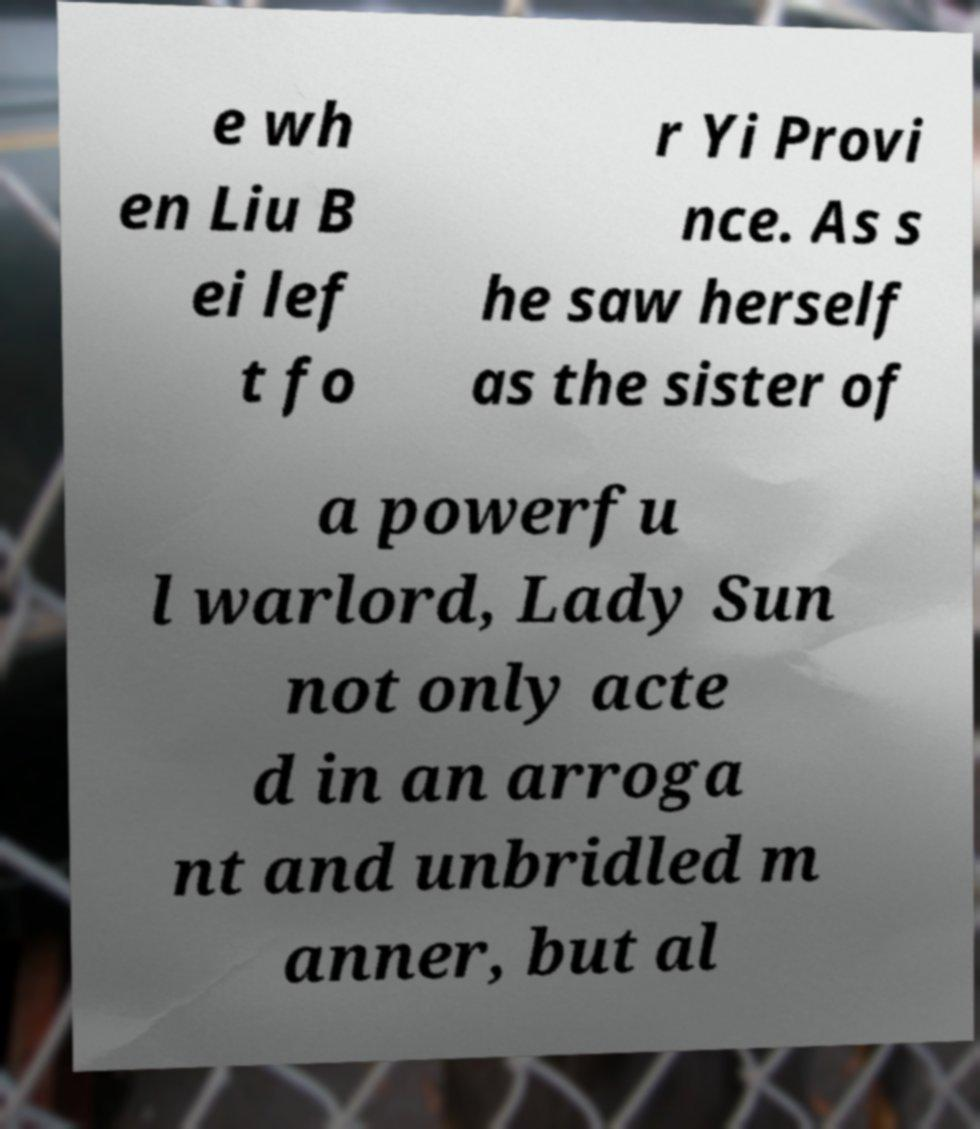For documentation purposes, I need the text within this image transcribed. Could you provide that? e wh en Liu B ei lef t fo r Yi Provi nce. As s he saw herself as the sister of a powerfu l warlord, Lady Sun not only acte d in an arroga nt and unbridled m anner, but al 